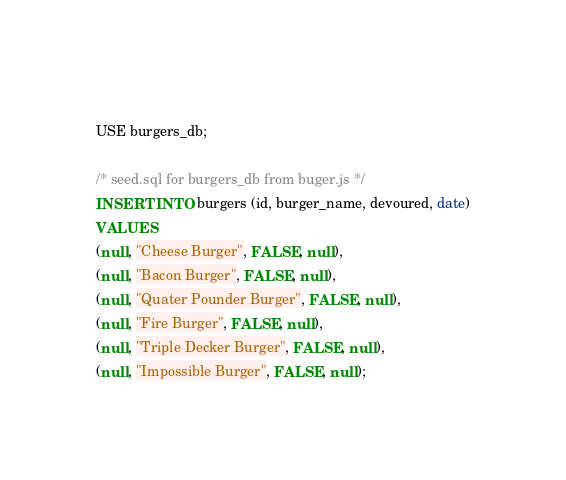Convert code to text. <code><loc_0><loc_0><loc_500><loc_500><_SQL_>  
USE burgers_db;

/* seed.sql for burgers_db from buger.js */
INSERT INTO burgers (id, burger_name, devoured, date)
VALUES
(null, "Cheese Burger", FALSE, null),
(null, "Bacon Burger", FALSE, null),
(null, "Quater Pounder Burger", FALSE, null),
(null, "Fire Burger", FALSE, null),
(null, "Triple Decker Burger", FALSE, null),
(null, "Impossible Burger", FALSE, null);</code> 